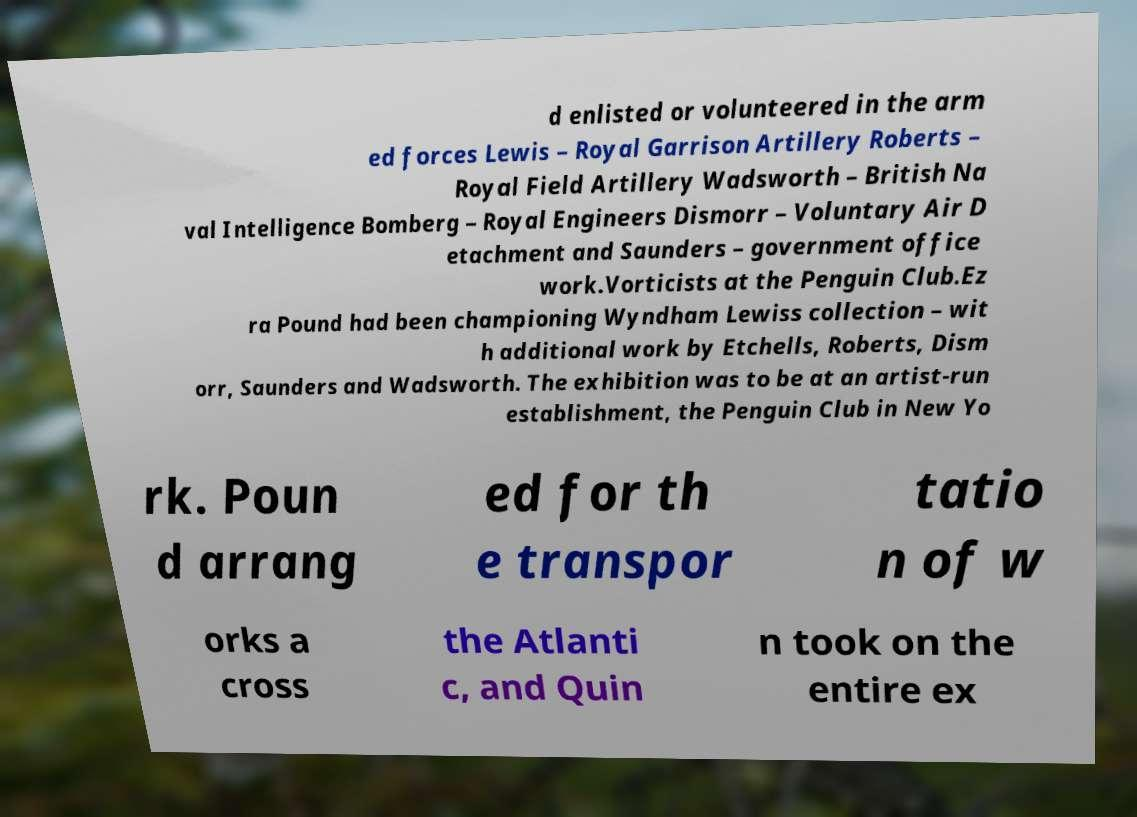Please identify and transcribe the text found in this image. d enlisted or volunteered in the arm ed forces Lewis – Royal Garrison Artillery Roberts – Royal Field Artillery Wadsworth – British Na val Intelligence Bomberg – Royal Engineers Dismorr – Voluntary Air D etachment and Saunders – government office work.Vorticists at the Penguin Club.Ez ra Pound had been championing Wyndham Lewiss collection – wit h additional work by Etchells, Roberts, Dism orr, Saunders and Wadsworth. The exhibition was to be at an artist-run establishment, the Penguin Club in New Yo rk. Poun d arrang ed for th e transpor tatio n of w orks a cross the Atlanti c, and Quin n took on the entire ex 